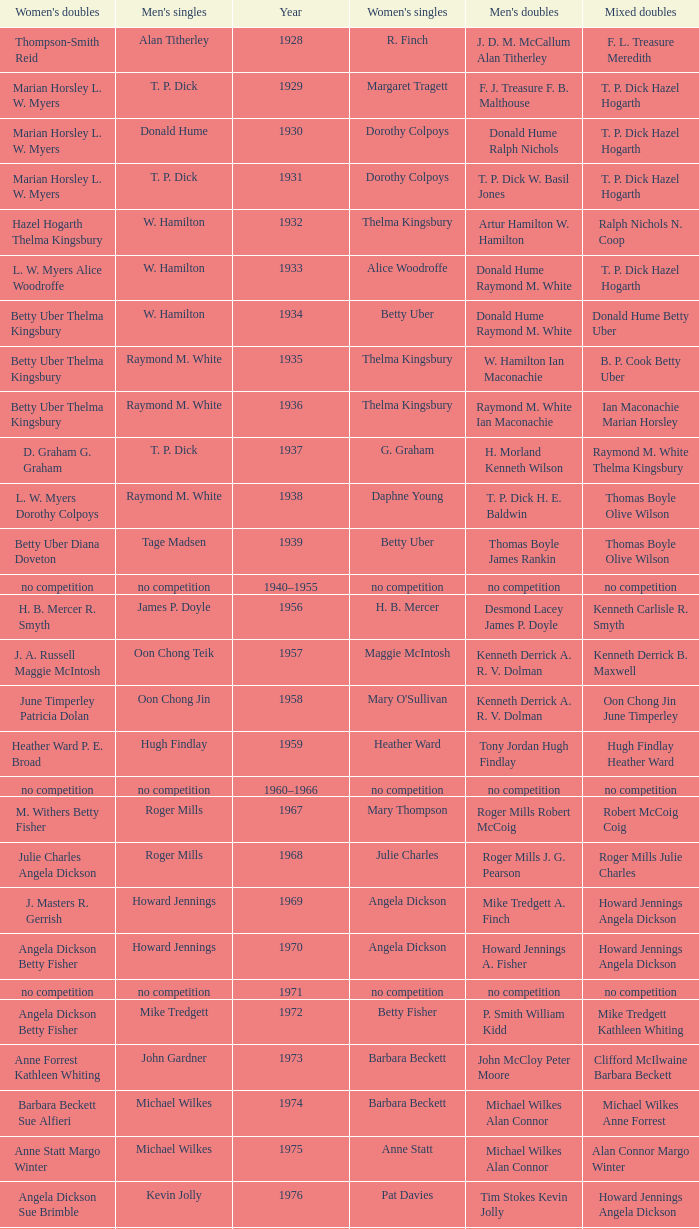Who won the Women's doubles in the year that David Eddy Eddy Sutton won the Men's doubles, and that David Eddy won the Men's singles? Anne Statt Jane Webster. 